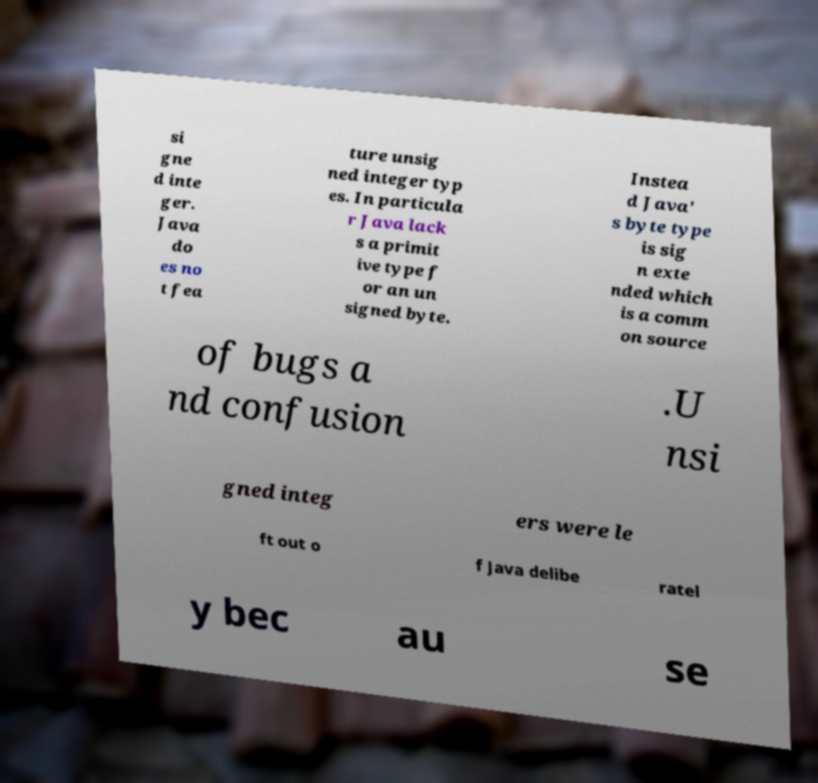For documentation purposes, I need the text within this image transcribed. Could you provide that? si gne d inte ger. Java do es no t fea ture unsig ned integer typ es. In particula r Java lack s a primit ive type f or an un signed byte. Instea d Java' s byte type is sig n exte nded which is a comm on source of bugs a nd confusion .U nsi gned integ ers were le ft out o f Java delibe ratel y bec au se 